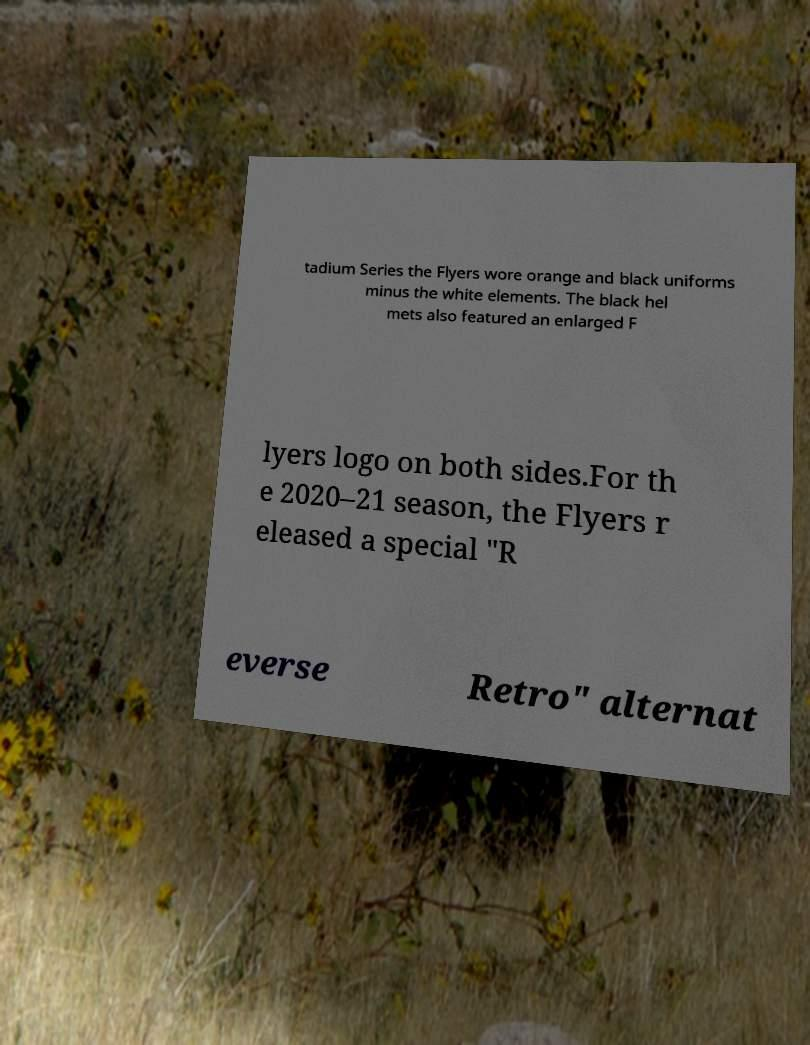Please read and relay the text visible in this image. What does it say? tadium Series the Flyers wore orange and black uniforms minus the white elements. The black hel mets also featured an enlarged F lyers logo on both sides.For th e 2020–21 season, the Flyers r eleased a special "R everse Retro" alternat 